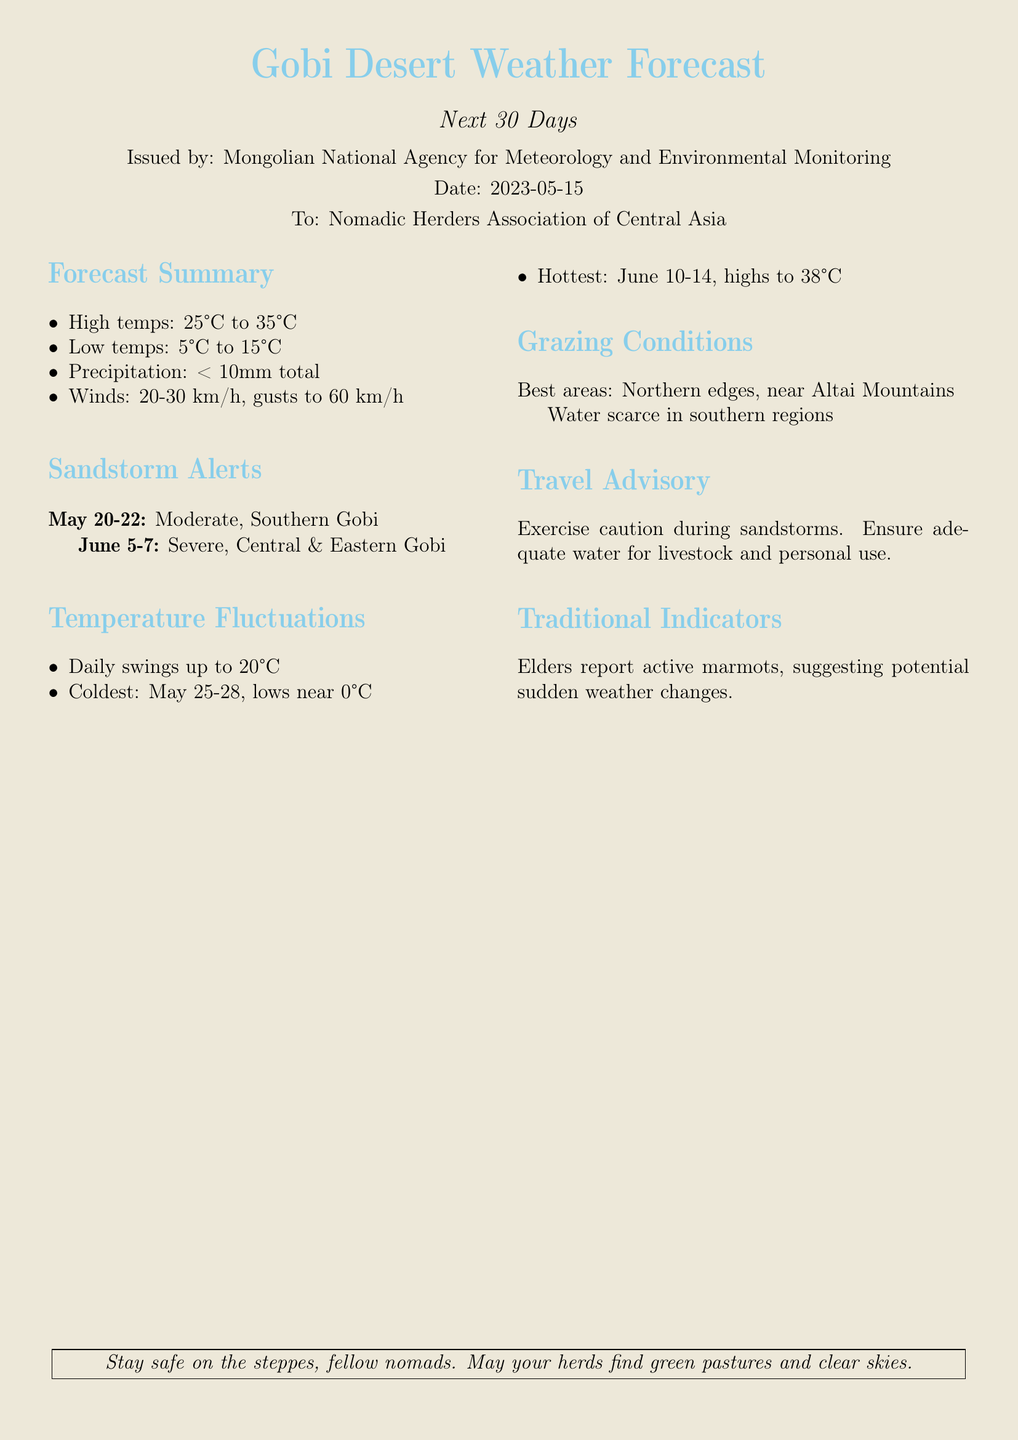What are the expected high temperatures? The document specifies high temperatures in the range of 25°C to 35°C.
Answer: 25°C to 35°C When is the first sandstorm expected? The document indicates the first sandstorm alert is for May 20-22.
Answer: May 20-22 What are the coldest days noted in the forecast? The coldest days mentioned are from May 25-28, with lows near 0°C.
Answer: May 25-28 What is the expected total precipitation? The document states that total precipitation is expected to be less than 10mm.
Answer: < 10mm total Which areas are best for grazing according to the forecast? The best grazing areas noted in the document are the northern edges, near the Altai Mountains.
Answer: Northern edges, near Altai Mountains What is the warning issued for sandstorms? The document advises exercising caution during sandstorms and ensuring adequate water supply.
Answer: Exercise caution during sandstorms What temperature fluctuations are expected daily? The forecast mentions daily temperature swings of up to 20°C.
Answer: Up to 20°C When are the hottest days expected? The document indicates that the hottest days are expected from June 10-14.
Answer: June 10-14 What traditional indicator is mentioned regarding weather changes? The document states that elders report active marmots as a traditional weather indicator.
Answer: Active marmots 